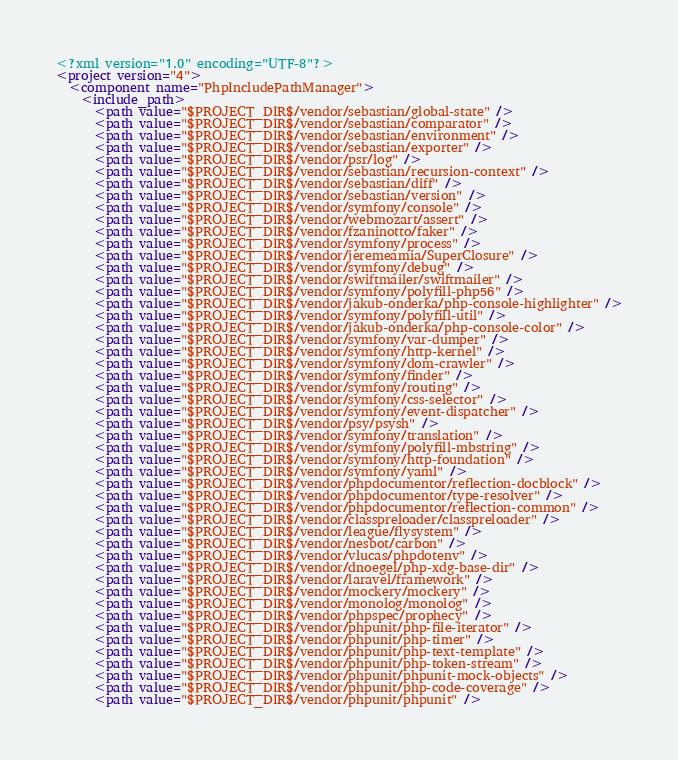<code> <loc_0><loc_0><loc_500><loc_500><_XML_><?xml version="1.0" encoding="UTF-8"?>
<project version="4">
  <component name="PhpIncludePathManager">
    <include_path>
      <path value="$PROJECT_DIR$/vendor/sebastian/global-state" />
      <path value="$PROJECT_DIR$/vendor/sebastian/comparator" />
      <path value="$PROJECT_DIR$/vendor/sebastian/environment" />
      <path value="$PROJECT_DIR$/vendor/sebastian/exporter" />
      <path value="$PROJECT_DIR$/vendor/psr/log" />
      <path value="$PROJECT_DIR$/vendor/sebastian/recursion-context" />
      <path value="$PROJECT_DIR$/vendor/sebastian/diff" />
      <path value="$PROJECT_DIR$/vendor/sebastian/version" />
      <path value="$PROJECT_DIR$/vendor/symfony/console" />
      <path value="$PROJECT_DIR$/vendor/webmozart/assert" />
      <path value="$PROJECT_DIR$/vendor/fzaninotto/faker" />
      <path value="$PROJECT_DIR$/vendor/symfony/process" />
      <path value="$PROJECT_DIR$/vendor/jeremeamia/SuperClosure" />
      <path value="$PROJECT_DIR$/vendor/symfony/debug" />
      <path value="$PROJECT_DIR$/vendor/swiftmailer/swiftmailer" />
      <path value="$PROJECT_DIR$/vendor/symfony/polyfill-php56" />
      <path value="$PROJECT_DIR$/vendor/jakub-onderka/php-console-highlighter" />
      <path value="$PROJECT_DIR$/vendor/symfony/polyfill-util" />
      <path value="$PROJECT_DIR$/vendor/jakub-onderka/php-console-color" />
      <path value="$PROJECT_DIR$/vendor/symfony/var-dumper" />
      <path value="$PROJECT_DIR$/vendor/symfony/http-kernel" />
      <path value="$PROJECT_DIR$/vendor/symfony/dom-crawler" />
      <path value="$PROJECT_DIR$/vendor/symfony/finder" />
      <path value="$PROJECT_DIR$/vendor/symfony/routing" />
      <path value="$PROJECT_DIR$/vendor/symfony/css-selector" />
      <path value="$PROJECT_DIR$/vendor/symfony/event-dispatcher" />
      <path value="$PROJECT_DIR$/vendor/psy/psysh" />
      <path value="$PROJECT_DIR$/vendor/symfony/translation" />
      <path value="$PROJECT_DIR$/vendor/symfony/polyfill-mbstring" />
      <path value="$PROJECT_DIR$/vendor/symfony/http-foundation" />
      <path value="$PROJECT_DIR$/vendor/symfony/yaml" />
      <path value="$PROJECT_DIR$/vendor/phpdocumentor/reflection-docblock" />
      <path value="$PROJECT_DIR$/vendor/phpdocumentor/type-resolver" />
      <path value="$PROJECT_DIR$/vendor/phpdocumentor/reflection-common" />
      <path value="$PROJECT_DIR$/vendor/classpreloader/classpreloader" />
      <path value="$PROJECT_DIR$/vendor/league/flysystem" />
      <path value="$PROJECT_DIR$/vendor/nesbot/carbon" />
      <path value="$PROJECT_DIR$/vendor/vlucas/phpdotenv" />
      <path value="$PROJECT_DIR$/vendor/dnoegel/php-xdg-base-dir" />
      <path value="$PROJECT_DIR$/vendor/laravel/framework" />
      <path value="$PROJECT_DIR$/vendor/mockery/mockery" />
      <path value="$PROJECT_DIR$/vendor/monolog/monolog" />
      <path value="$PROJECT_DIR$/vendor/phpspec/prophecy" />
      <path value="$PROJECT_DIR$/vendor/phpunit/php-file-iterator" />
      <path value="$PROJECT_DIR$/vendor/phpunit/php-timer" />
      <path value="$PROJECT_DIR$/vendor/phpunit/php-text-template" />
      <path value="$PROJECT_DIR$/vendor/phpunit/php-token-stream" />
      <path value="$PROJECT_DIR$/vendor/phpunit/phpunit-mock-objects" />
      <path value="$PROJECT_DIR$/vendor/phpunit/php-code-coverage" />
      <path value="$PROJECT_DIR$/vendor/phpunit/phpunit" /></code> 